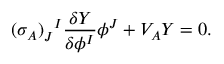<formula> <loc_0><loc_0><loc_500><loc_500>( \sigma _ { A } ) _ { J } ^ { \, I } \frac { \delta Y } { \delta \phi ^ { I } } \phi ^ { J } + V _ { A } Y = 0 .</formula> 